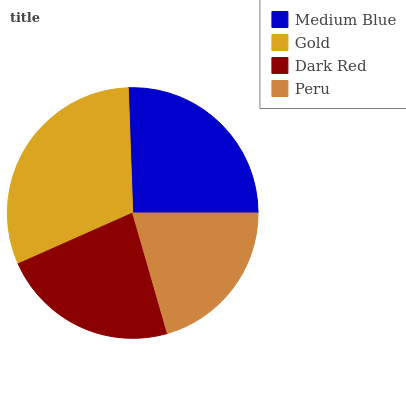Is Peru the minimum?
Answer yes or no. Yes. Is Gold the maximum?
Answer yes or no. Yes. Is Dark Red the minimum?
Answer yes or no. No. Is Dark Red the maximum?
Answer yes or no. No. Is Gold greater than Dark Red?
Answer yes or no. Yes. Is Dark Red less than Gold?
Answer yes or no. Yes. Is Dark Red greater than Gold?
Answer yes or no. No. Is Gold less than Dark Red?
Answer yes or no. No. Is Medium Blue the high median?
Answer yes or no. Yes. Is Dark Red the low median?
Answer yes or no. Yes. Is Dark Red the high median?
Answer yes or no. No. Is Gold the low median?
Answer yes or no. No. 